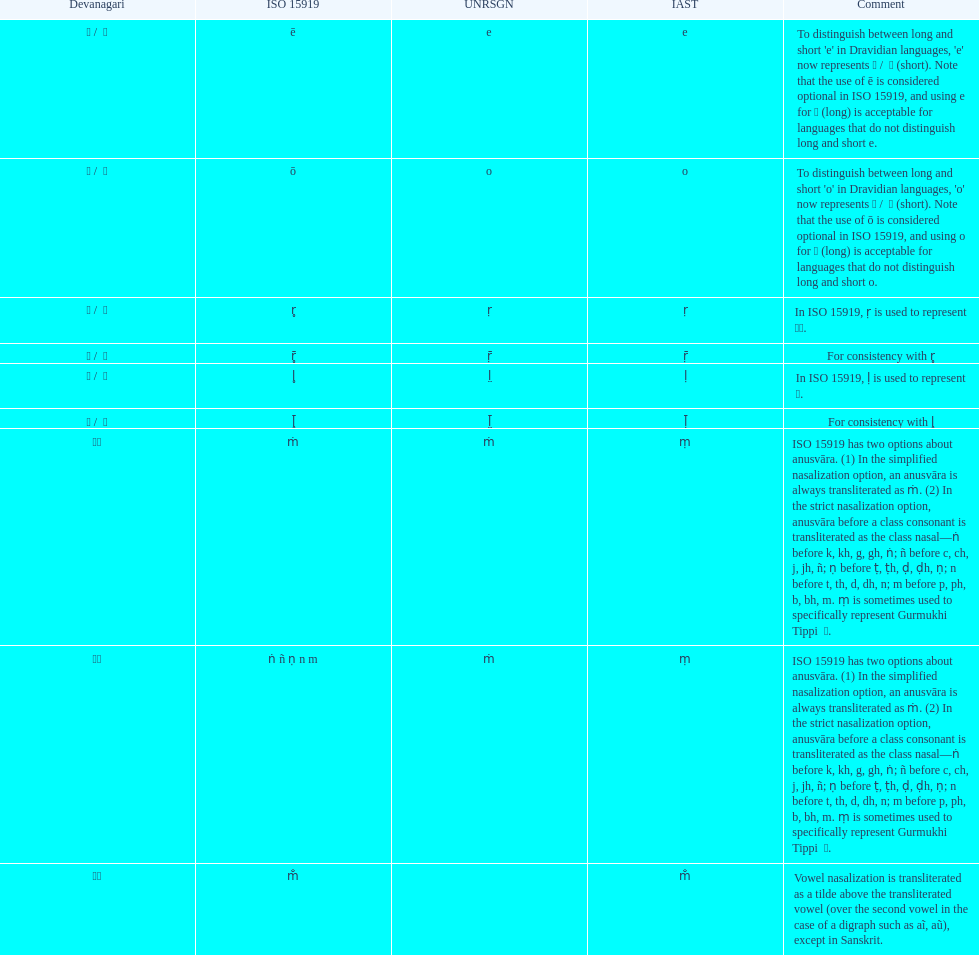What unrsgn is mentioned before the o? E. 